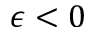<formula> <loc_0><loc_0><loc_500><loc_500>\epsilon < 0</formula> 